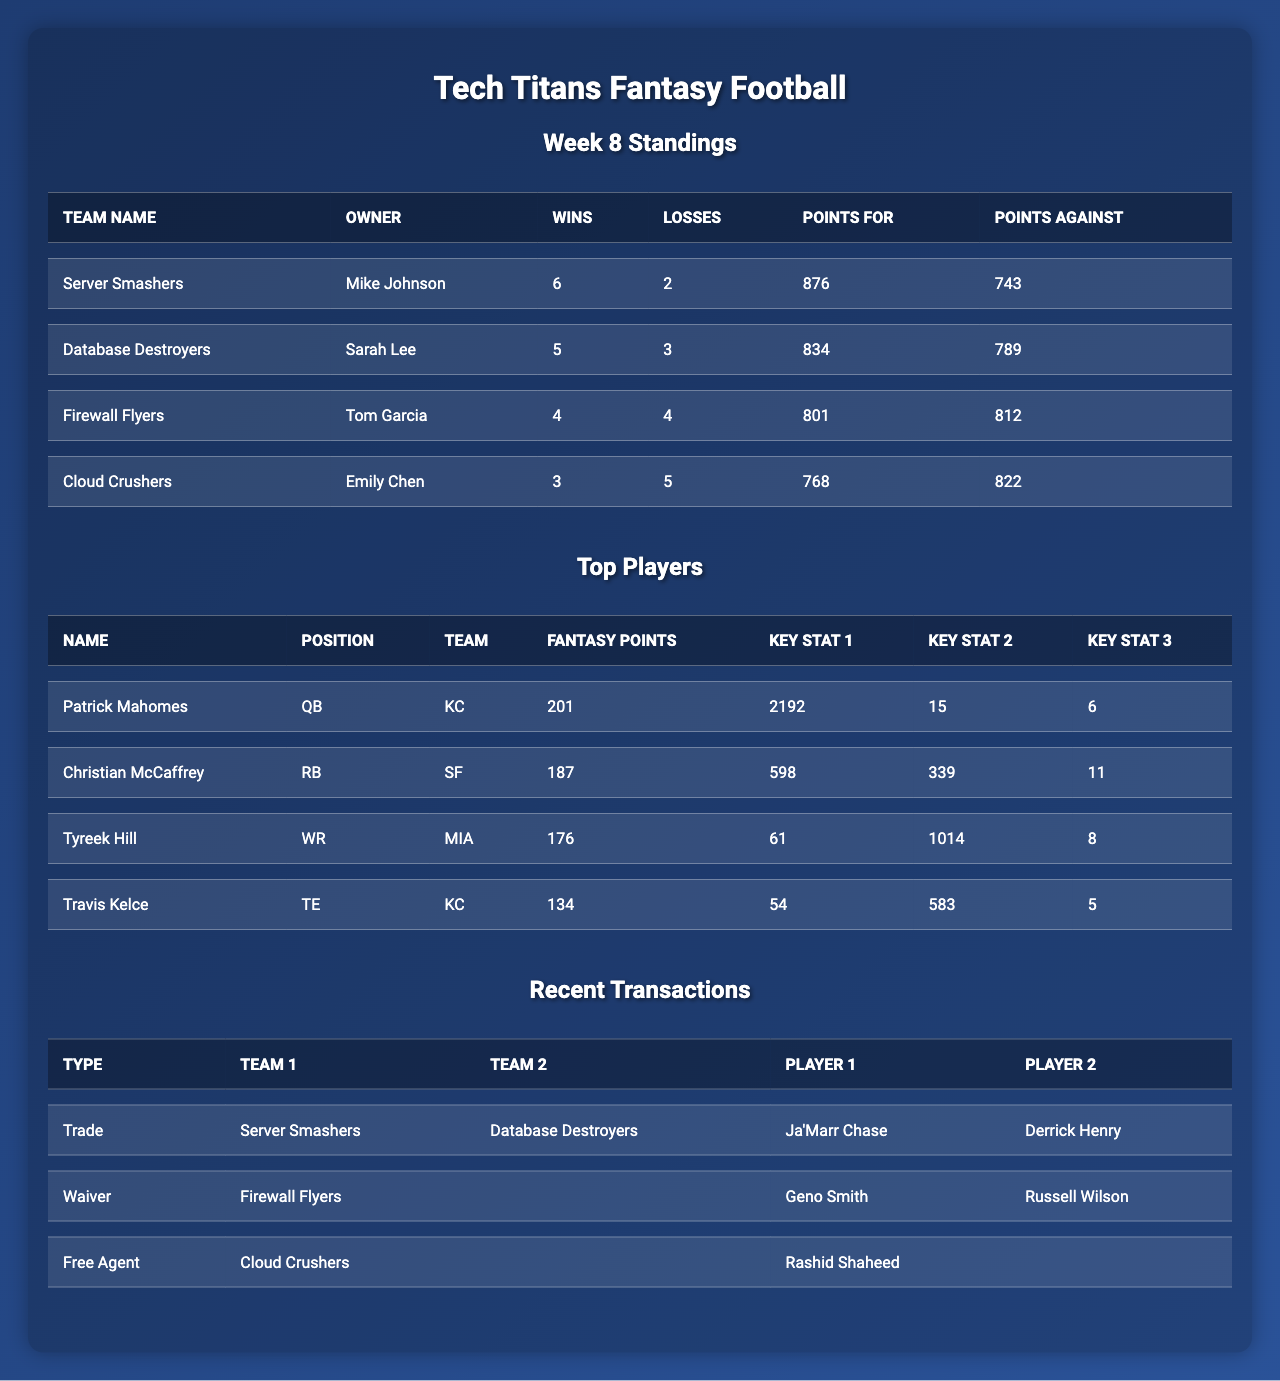What is the record of the Server Smashers? The table shows the Server Smashers have 6 wins and 2 losses, which constitutes their record.
Answer: 6-2 Which team has the highest points for? By checking the points for column, the Server Smashers have the highest points for with a total of 876.
Answer: 876 Who is the top scoring player in fantasy points? Looking at the top players, Patrick Mahomes has the highest fantasy points at 201.
Answer: 201 What is the total number of wins for the Firewall Flyers? The table indicates that the Firewall Flyers have 4 wins listed under the wins column.
Answer: 4 Is it true that the Database Destroyers have more points against than the points for? The Database Destroyers have 834 points for and 789 points against, confirming it is not true that they have more points against.
Answer: No How many points did Christian McCaffrey score compared to Tyreek Hill? Christian McCaffrey scored 187 points while Tyreek Hill scored 176 points, showing a difference of 11 points between them.
Answer: 11 What is the average number of fantasy points scored by the top four players? Adding the fantasy points (201 + 187 + 176 + 134) gives 698. Dividing by 4, the average fantasy points is 174.5.
Answer: 174.5 How many transactions did the Cloud Crushers make? The table shows only one entry under recent transactions for the Cloud Crushers, indicating they made one recent transaction.
Answer: 1 Did the Server Smashers trade Ja'Marr Chase for Derrick Henry? The table states that the Server Smashers did trade Ja'Marr Chase for Derrick Henry, confirming this statement.
Answer: Yes What is the difference in wins between the team with the most wins and the team with the least wins? The team with the most wins (Server Smashers) has 6 wins and the team with the least wins (Cloud Crushers) has 3 wins; thus, the difference is 6 - 3 = 3.
Answer: 3 